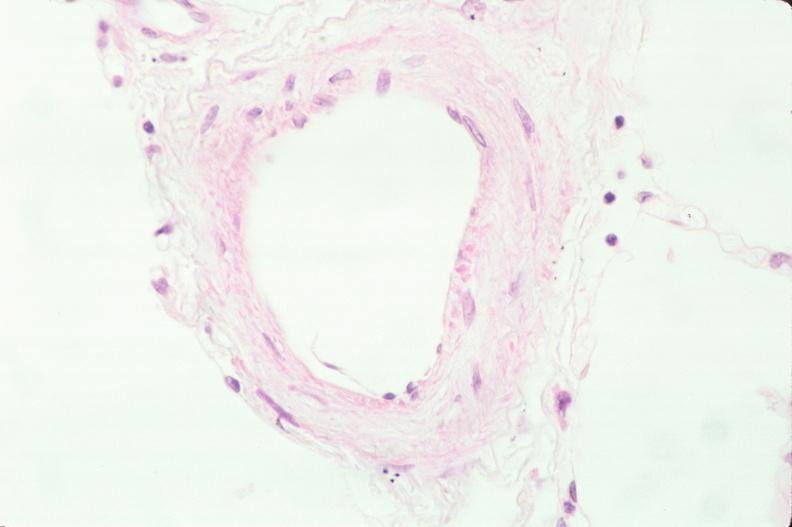s respiratory present?
Answer the question using a single word or phrase. Yes 